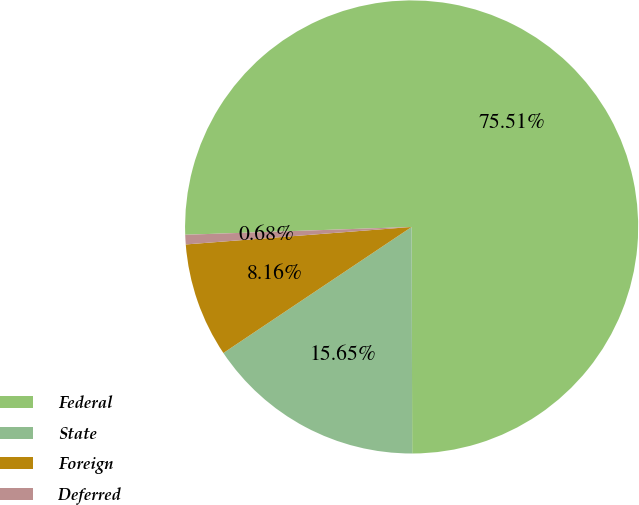Convert chart to OTSL. <chart><loc_0><loc_0><loc_500><loc_500><pie_chart><fcel>Federal<fcel>State<fcel>Foreign<fcel>Deferred<nl><fcel>75.51%<fcel>15.65%<fcel>8.16%<fcel>0.68%<nl></chart> 